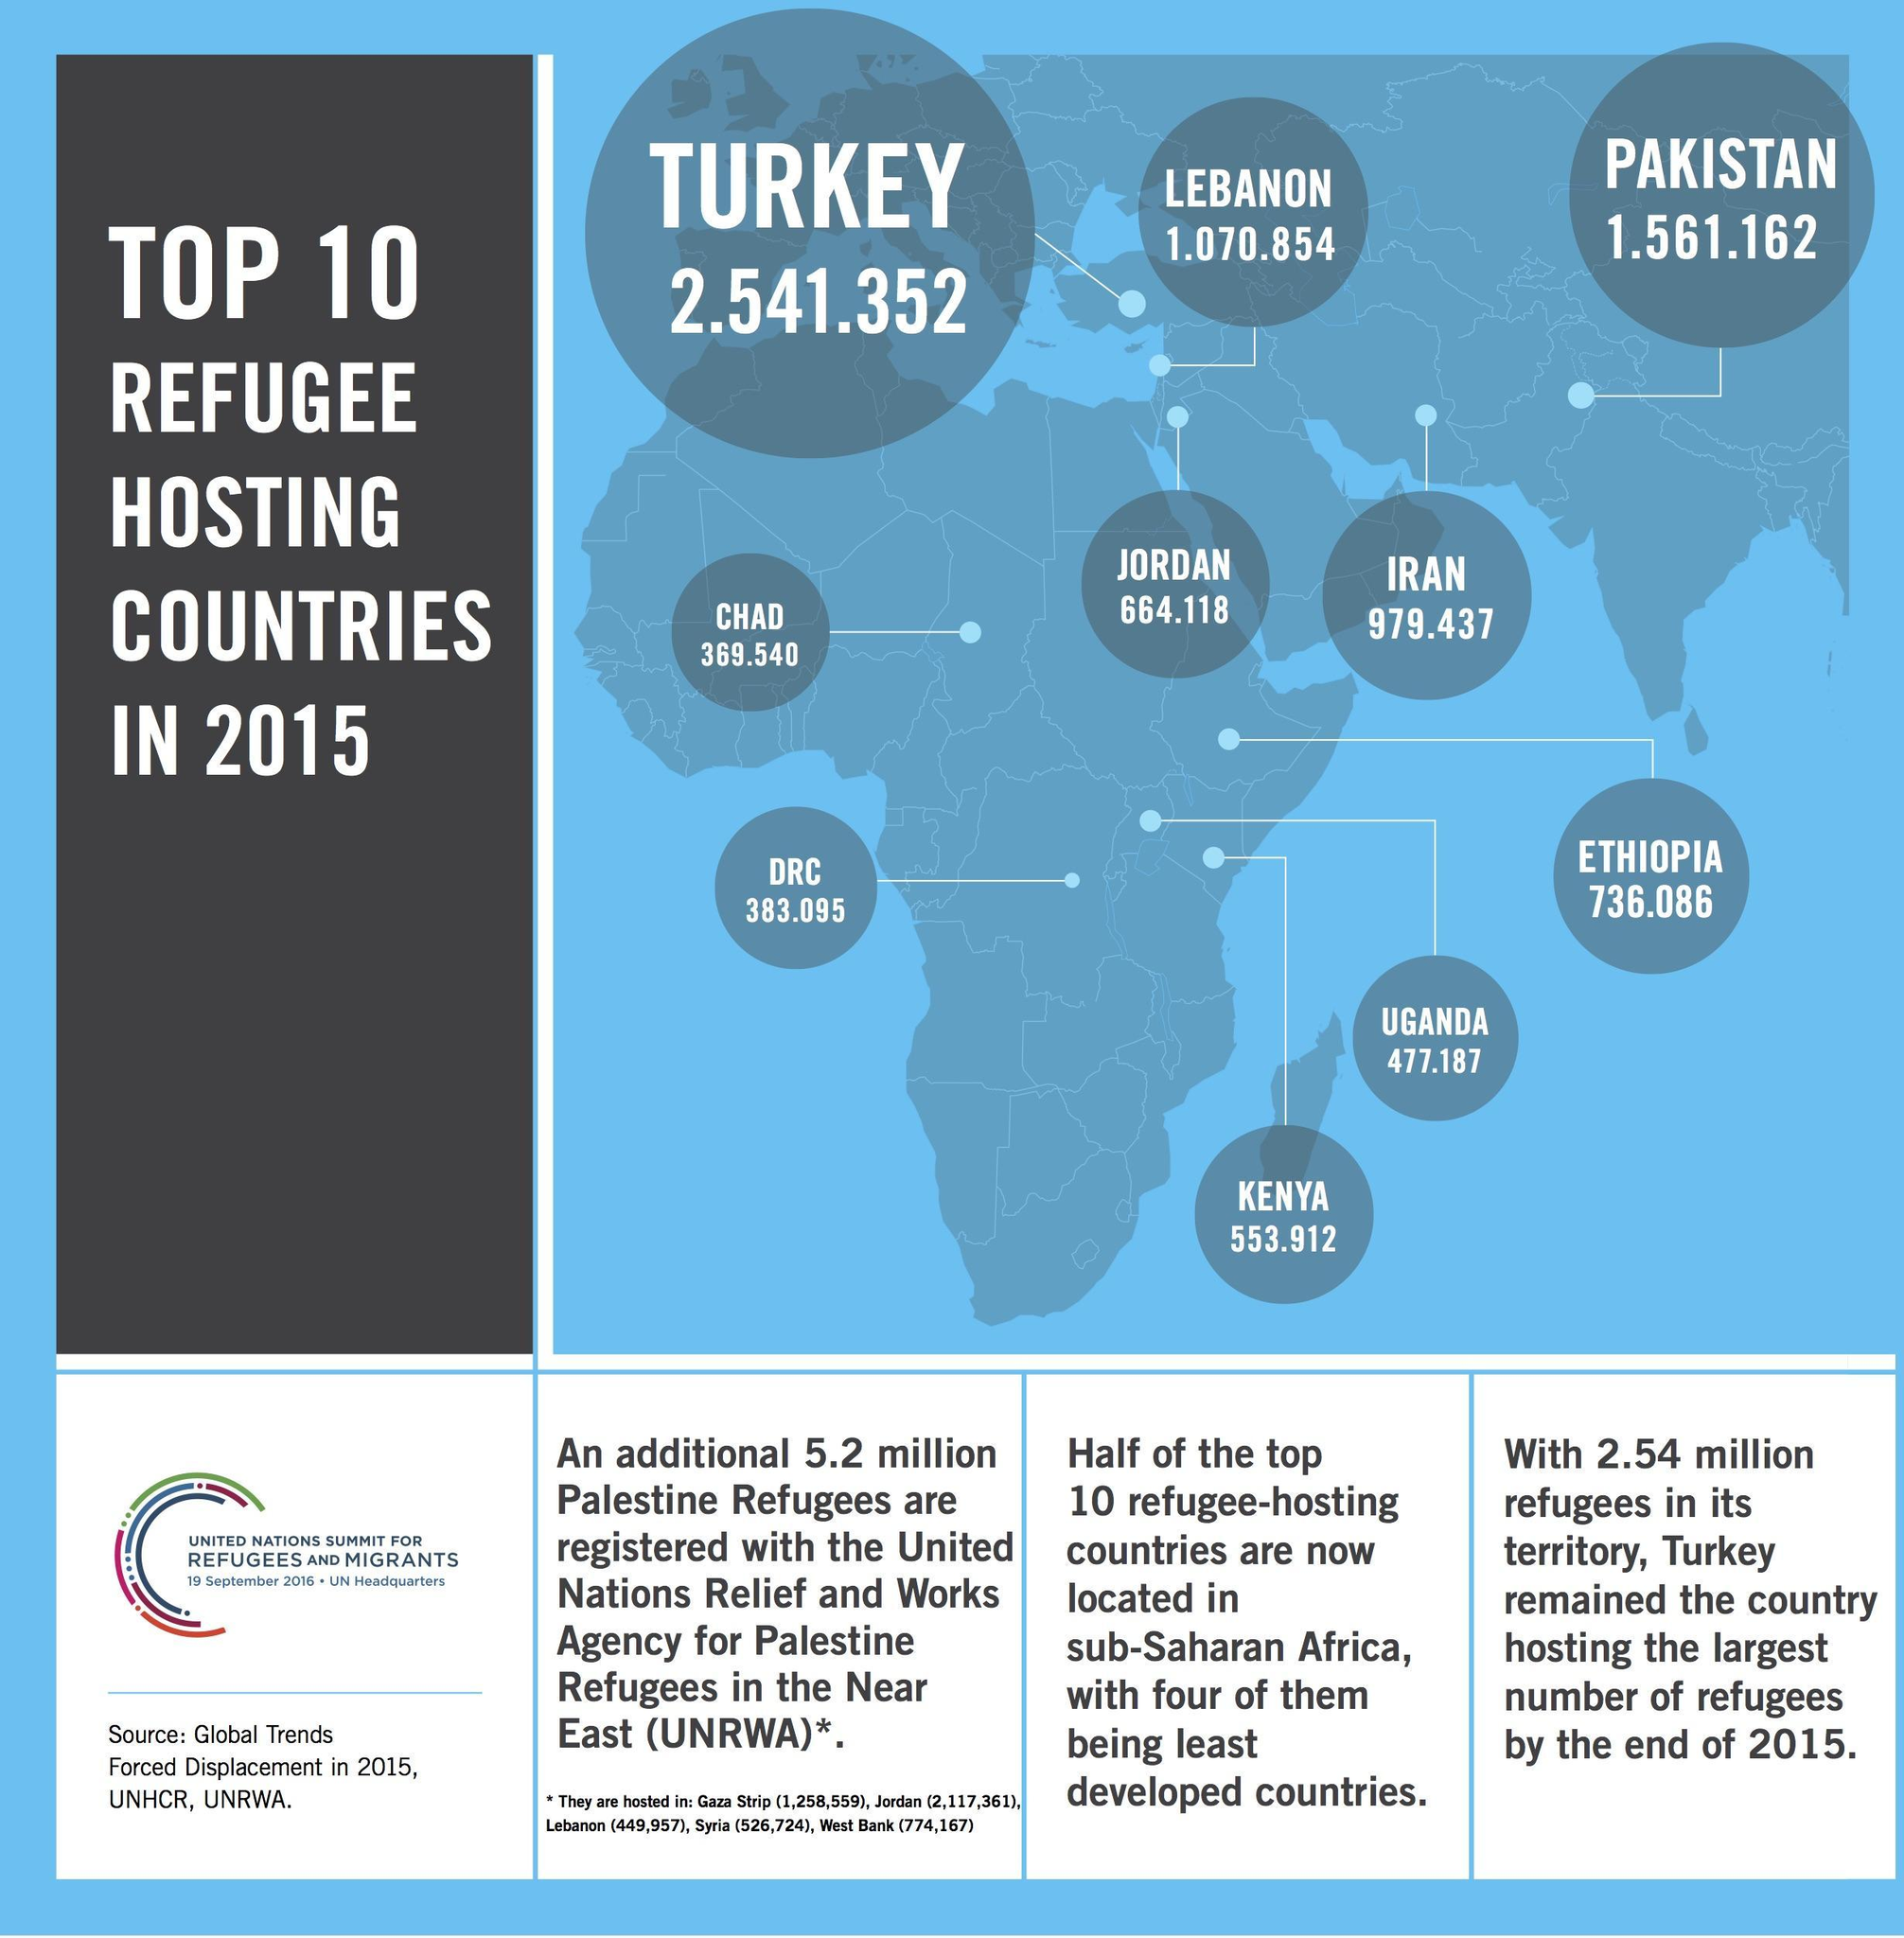Which country hosted the second highest number of refugees in 2015?
Answer the question with a short phrase. PAKISTAN Which country hosted the least number of refugees in 2015? CHAD How many refugees were hosted by Pakistan in 2015? 1.561.162 Which country hosted the highest number of refugees in 2015? TURKEY How many refugees were hosted by Iran in 2015? 979.437 